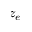Convert formula to latex. <formula><loc_0><loc_0><loc_500><loc_500>z _ { e }</formula> 